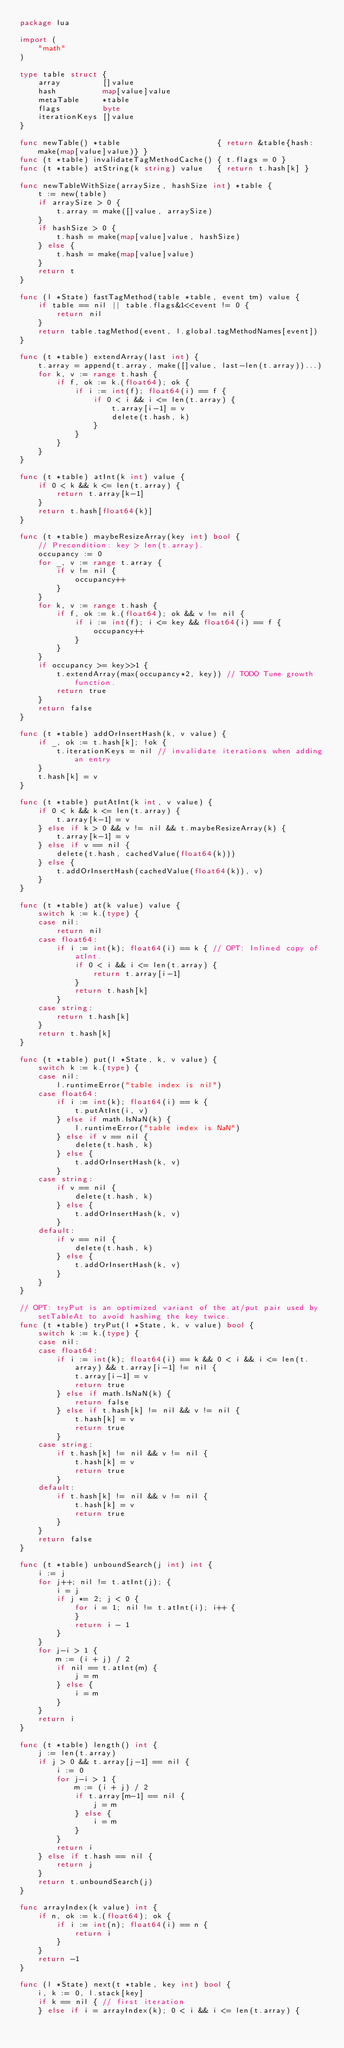<code> <loc_0><loc_0><loc_500><loc_500><_Go_>package lua

import (
	"math"
)

type table struct {
	array         []value
	hash          map[value]value
	metaTable     *table
	flags         byte
	iterationKeys []value
}

func newTable() *table                     { return &table{hash: make(map[value]value)} }
func (t *table) invalidateTagMethodCache() { t.flags = 0 }
func (t *table) atString(k string) value   { return t.hash[k] }

func newTableWithSize(arraySize, hashSize int) *table {
	t := new(table)
	if arraySize > 0 {
		t.array = make([]value, arraySize)
	}
	if hashSize > 0 {
		t.hash = make(map[value]value, hashSize)
	} else {
		t.hash = make(map[value]value)
	}
	return t
}

func (l *State) fastTagMethod(table *table, event tm) value {
	if table == nil || table.flags&1<<event != 0 {
		return nil
	}
	return table.tagMethod(event, l.global.tagMethodNames[event])
}

func (t *table) extendArray(last int) {
	t.array = append(t.array, make([]value, last-len(t.array))...)
	for k, v := range t.hash {
		if f, ok := k.(float64); ok {
			if i := int(f); float64(i) == f {
				if 0 < i && i <= len(t.array) {
					t.array[i-1] = v
					delete(t.hash, k)
				}
			}
		}
	}
}

func (t *table) atInt(k int) value {
	if 0 < k && k <= len(t.array) {
		return t.array[k-1]
	}
	return t.hash[float64(k)]
}

func (t *table) maybeResizeArray(key int) bool {
	// Precondition: key > len(t.array).
	occupancy := 0
	for _, v := range t.array {
		if v != nil {
			occupancy++
		}
	}
	for k, v := range t.hash {
		if f, ok := k.(float64); ok && v != nil {
			if i := int(f); i <= key && float64(i) == f {
				occupancy++
			}
		}
	}
	if occupancy >= key>>1 {
		t.extendArray(max(occupancy*2, key)) // TODO Tune growth function.
		return true
	}
	return false
}

func (t *table) addOrInsertHash(k, v value) {
	if _, ok := t.hash[k]; !ok {
		t.iterationKeys = nil // invalidate iterations when adding an entry
	}
	t.hash[k] = v
}

func (t *table) putAtInt(k int, v value) {
	if 0 < k && k <= len(t.array) {
		t.array[k-1] = v
	} else if k > 0 && v != nil && t.maybeResizeArray(k) {
		t.array[k-1] = v
	} else if v == nil {
		delete(t.hash, cachedValue(float64(k)))
	} else {
		t.addOrInsertHash(cachedValue(float64(k)), v)
	}
}

func (t *table) at(k value) value {
	switch k := k.(type) {
	case nil:
		return nil
	case float64:
		if i := int(k); float64(i) == k { // OPT: Inlined copy of atInt.
			if 0 < i && i <= len(t.array) {
				return t.array[i-1]
			}
			return t.hash[k]
		}
	case string:
		return t.hash[k]
	}
	return t.hash[k]
}

func (t *table) put(l *State, k, v value) {
	switch k := k.(type) {
	case nil:
		l.runtimeError("table index is nil")
	case float64:
		if i := int(k); float64(i) == k {
			t.putAtInt(i, v)
		} else if math.IsNaN(k) {
			l.runtimeError("table index is NaN")
		} else if v == nil {
			delete(t.hash, k)
		} else {
			t.addOrInsertHash(k, v)
		}
	case string:
		if v == nil {
			delete(t.hash, k)
		} else {
			t.addOrInsertHash(k, v)
		}
	default:
		if v == nil {
			delete(t.hash, k)
		} else {
			t.addOrInsertHash(k, v)
		}
	}
}

// OPT: tryPut is an optimized variant of the at/put pair used by setTableAt to avoid hashing the key twice.
func (t *table) tryPut(l *State, k, v value) bool {
	switch k := k.(type) {
	case nil:
	case float64:
		if i := int(k); float64(i) == k && 0 < i && i <= len(t.array) && t.array[i-1] != nil {
			t.array[i-1] = v
			return true
		} else if math.IsNaN(k) {
			return false
		} else if t.hash[k] != nil && v != nil {
			t.hash[k] = v
			return true
		}
	case string:
		if t.hash[k] != nil && v != nil {
			t.hash[k] = v
			return true
		}
	default:
		if t.hash[k] != nil && v != nil {
			t.hash[k] = v
			return true
		}
	}
	return false
}

func (t *table) unboundSearch(j int) int {
	i := j
	for j++; nil != t.atInt(j); {
		i = j
		if j *= 2; j < 0 {
			for i = 1; nil != t.atInt(i); i++ {
			}
			return i - 1
		}
	}
	for j-i > 1 {
		m := (i + j) / 2
		if nil == t.atInt(m) {
			j = m
		} else {
			i = m
		}
	}
	return i
}

func (t *table) length() int {
	j := len(t.array)
	if j > 0 && t.array[j-1] == nil {
		i := 0
		for j-i > 1 {
			m := (i + j) / 2
			if t.array[m-1] == nil {
				j = m
			} else {
				i = m
			}
		}
		return i
	} else if t.hash == nil {
		return j
	}
	return t.unboundSearch(j)
}

func arrayIndex(k value) int {
	if n, ok := k.(float64); ok {
		if i := int(n); float64(i) == n {
			return i
		}
	}
	return -1
}

func (l *State) next(t *table, key int) bool {
	i, k := 0, l.stack[key]
	if k == nil { // first iteration
	} else if i = arrayIndex(k); 0 < i && i <= len(t.array) {</code> 